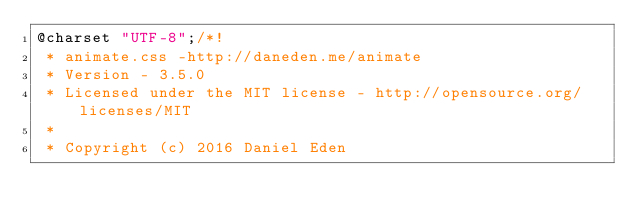<code> <loc_0><loc_0><loc_500><loc_500><_CSS_>@charset "UTF-8";/*!
 * animate.css -http://daneden.me/animate
 * Version - 3.5.0
 * Licensed under the MIT license - http://opensource.org/licenses/MIT
 *
 * Copyright (c) 2016 Daniel Eden</code> 